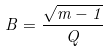<formula> <loc_0><loc_0><loc_500><loc_500>B = \frac { \sqrt { m - 1 } } { Q }</formula> 